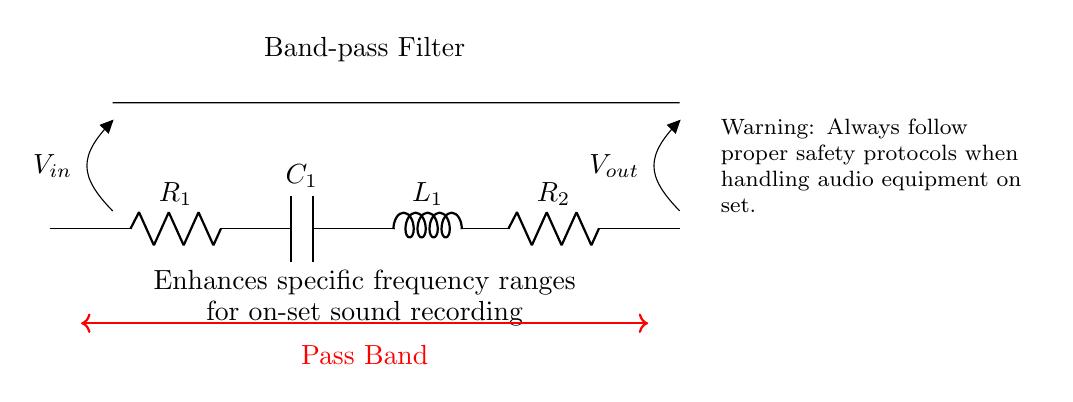What is the function of this circuit? The circuit is a band-pass filter, which allows specific frequency ranges to pass while attenuating others. This is detailed in the label on the diagram that states "Band-pass Filter."
Answer: Band-pass filter What is the first component in the circuit? The first component listed in the circuit diagram is a resistor labeled "R1," which is depicted on the left side of the circuit.
Answer: R1 How many components are there in total? Counting the components in the circuit, we identify two resistors, one capacitor, and one inductor, resulting in a total of five components.
Answer: Five What does "Vout" represent in the circuit? "Vout" indicates the output voltage, which is the potential difference measured across the output terminals of the circuit. It is marked in the diagram at the far right as "Vout."
Answer: Output voltage What is the purpose of including a capacitor in this filter? The capacitor, denoted as "C1," plays a critical role in controlling the frequency response of the band-pass filter by allowing AC signals to pass while blocking DC signals. This is essential for selecting specific frequency ranges.
Answer: Control frequency response What is the pass band range indicated in the circuit? The circuit includes a label indicating "Pass Band," which generally represents the range of frequencies that can pass through the filter without significant attenuation. This is marked in the diagram with a red arrow connecting the components.
Answer: Pass Band What safety protocol is mentioned in the circuit diagram? The warning included in the circuit diagram advises to "Always follow proper safety protocols when handling audio equipment on set," highlighting the importance of safety when working with electronic components.
Answer: Proper safety protocols 